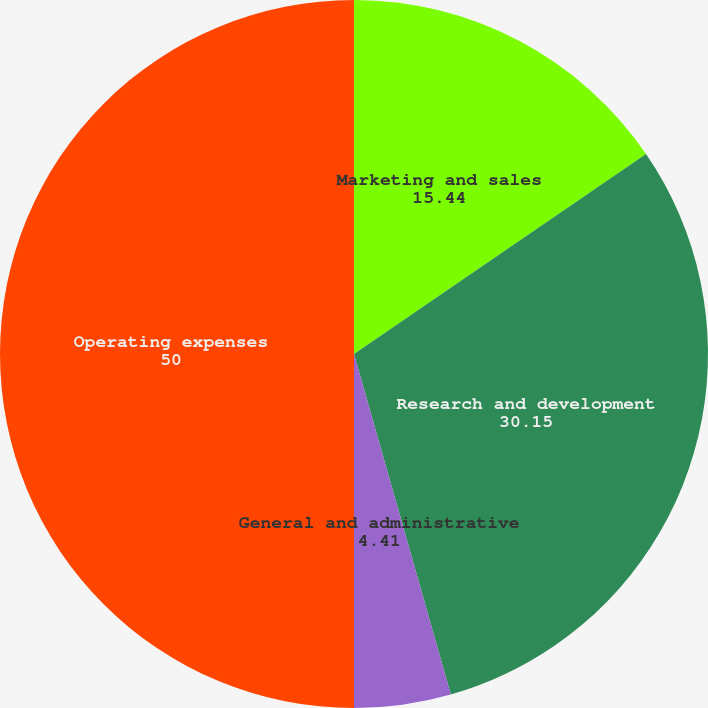Convert chart to OTSL. <chart><loc_0><loc_0><loc_500><loc_500><pie_chart><fcel>Marketing and sales<fcel>Research and development<fcel>General and administrative<fcel>Operating expenses<nl><fcel>15.44%<fcel>30.15%<fcel>4.41%<fcel>50.0%<nl></chart> 